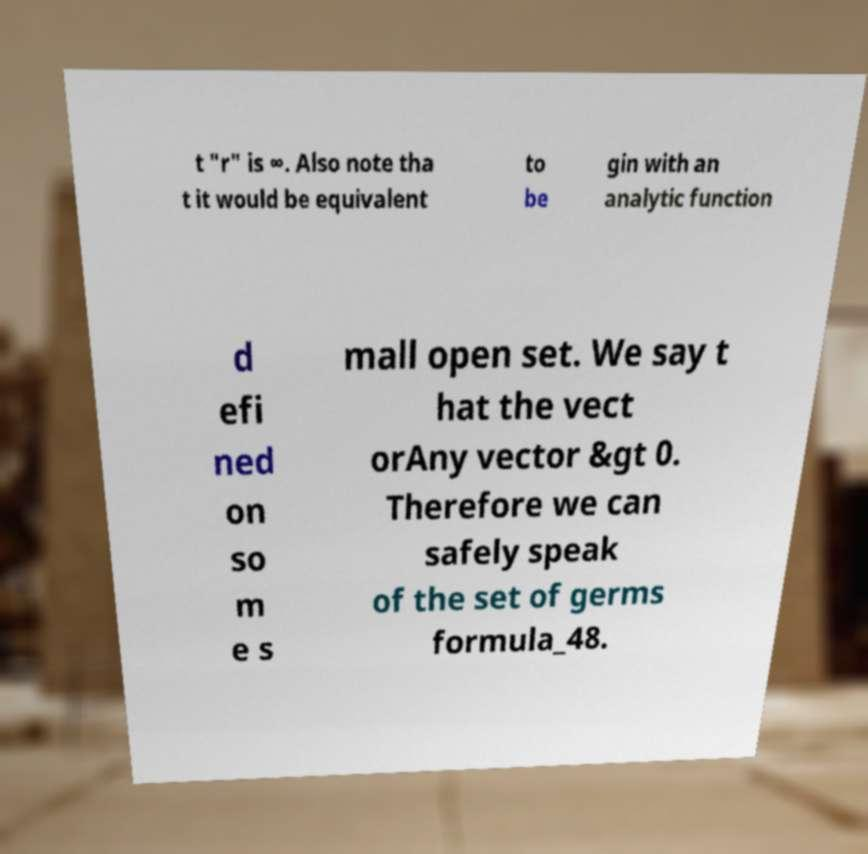Could you assist in decoding the text presented in this image and type it out clearly? t "r" is ∞. Also note tha t it would be equivalent to be gin with an analytic function d efi ned on so m e s mall open set. We say t hat the vect orAny vector &gt 0. Therefore we can safely speak of the set of germs formula_48. 